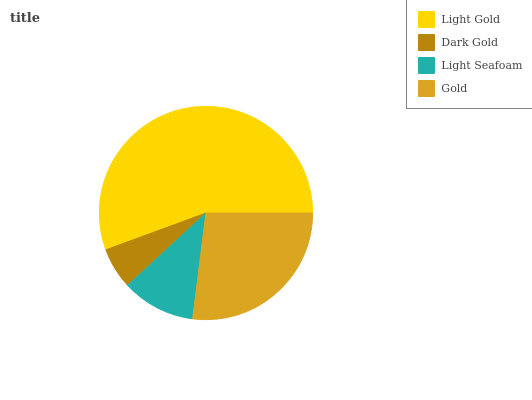Is Dark Gold the minimum?
Answer yes or no. Yes. Is Light Gold the maximum?
Answer yes or no. Yes. Is Light Seafoam the minimum?
Answer yes or no. No. Is Light Seafoam the maximum?
Answer yes or no. No. Is Light Seafoam greater than Dark Gold?
Answer yes or no. Yes. Is Dark Gold less than Light Seafoam?
Answer yes or no. Yes. Is Dark Gold greater than Light Seafoam?
Answer yes or no. No. Is Light Seafoam less than Dark Gold?
Answer yes or no. No. Is Gold the high median?
Answer yes or no. Yes. Is Light Seafoam the low median?
Answer yes or no. Yes. Is Dark Gold the high median?
Answer yes or no. No. Is Gold the low median?
Answer yes or no. No. 